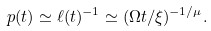<formula> <loc_0><loc_0><loc_500><loc_500>p ( t ) \simeq \ell ( t ) ^ { - 1 } \simeq ( \Omega t / \xi ) ^ { - 1 / \mu } .</formula> 